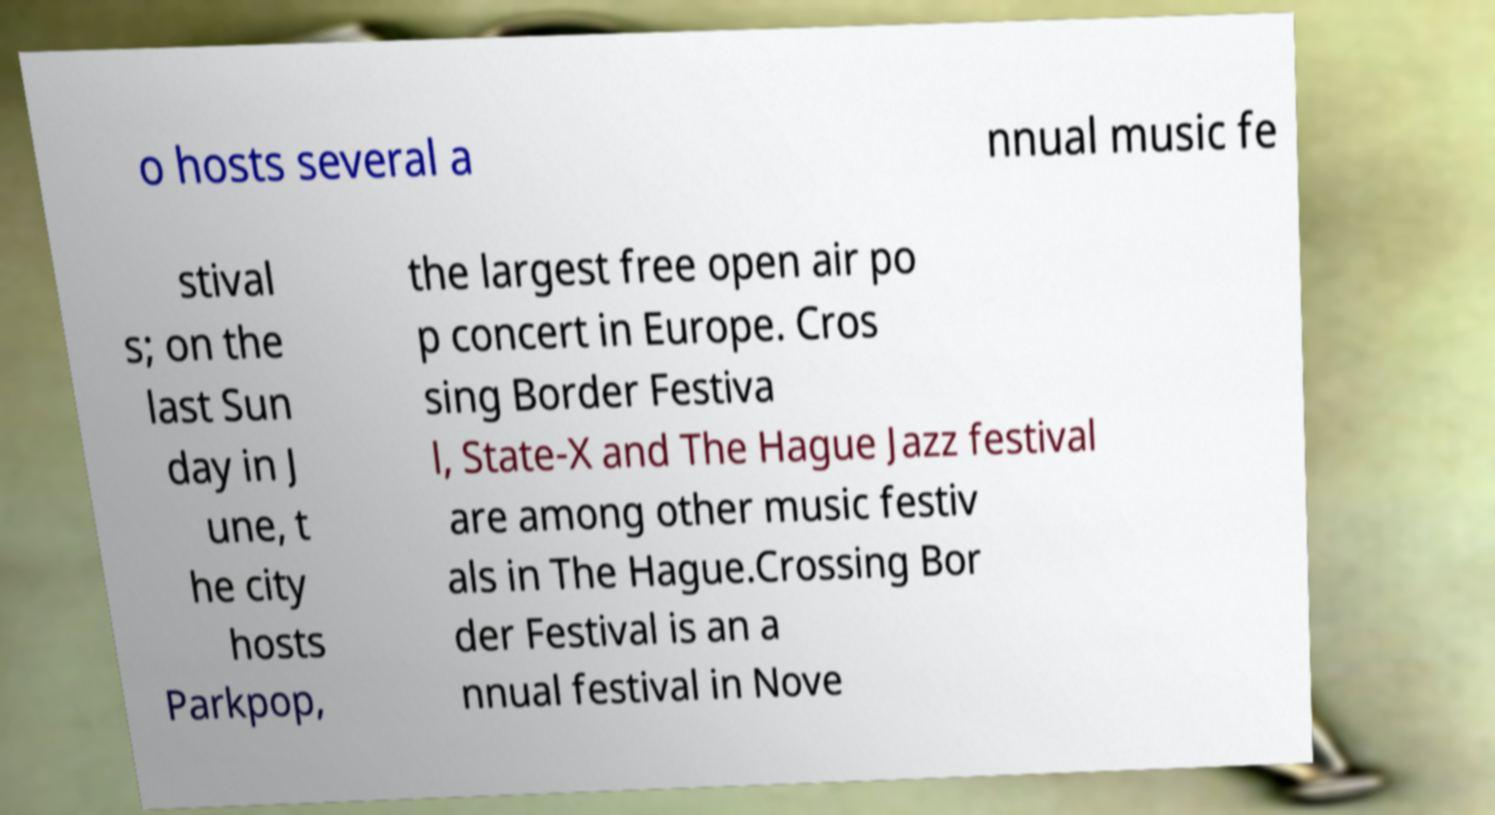Please read and relay the text visible in this image. What does it say? o hosts several a nnual music fe stival s; on the last Sun day in J une, t he city hosts Parkpop, the largest free open air po p concert in Europe. Cros sing Border Festiva l, State-X and The Hague Jazz festival are among other music festiv als in The Hague.Crossing Bor der Festival is an a nnual festival in Nove 